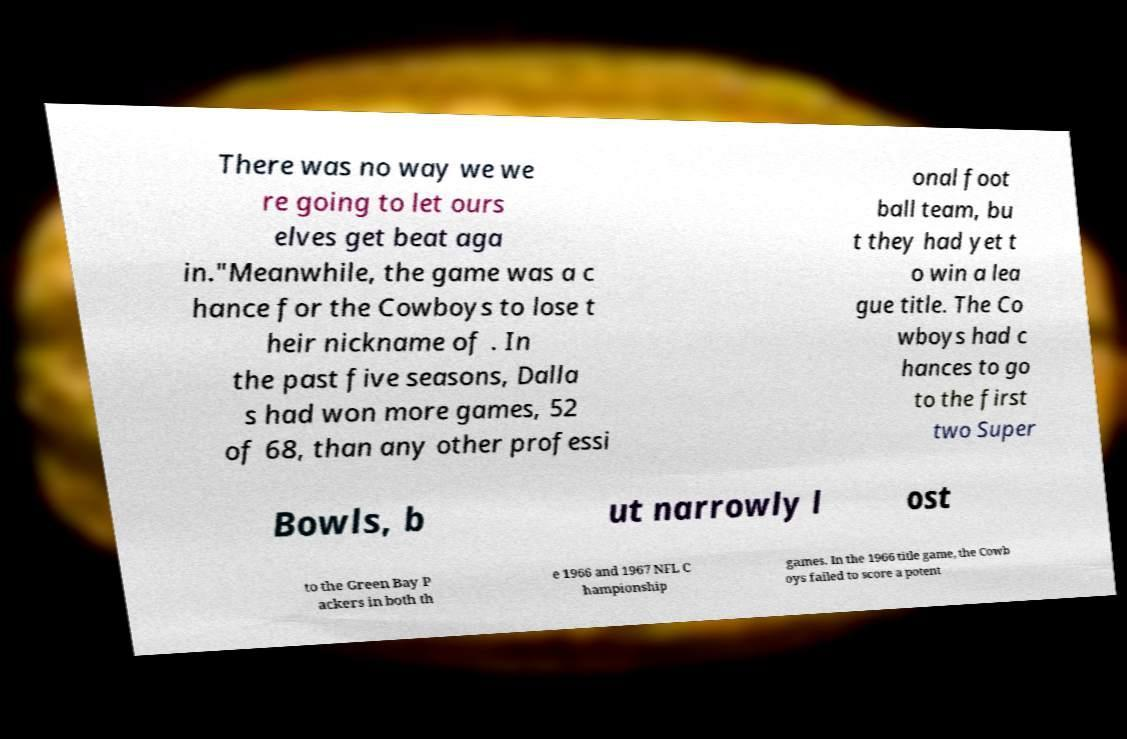What messages or text are displayed in this image? I need them in a readable, typed format. There was no way we we re going to let ours elves get beat aga in."Meanwhile, the game was a c hance for the Cowboys to lose t heir nickname of . In the past five seasons, Dalla s had won more games, 52 of 68, than any other professi onal foot ball team, bu t they had yet t o win a lea gue title. The Co wboys had c hances to go to the first two Super Bowls, b ut narrowly l ost to the Green Bay P ackers in both th e 1966 and 1967 NFL C hampionship games. In the 1966 title game, the Cowb oys failed to score a potent 